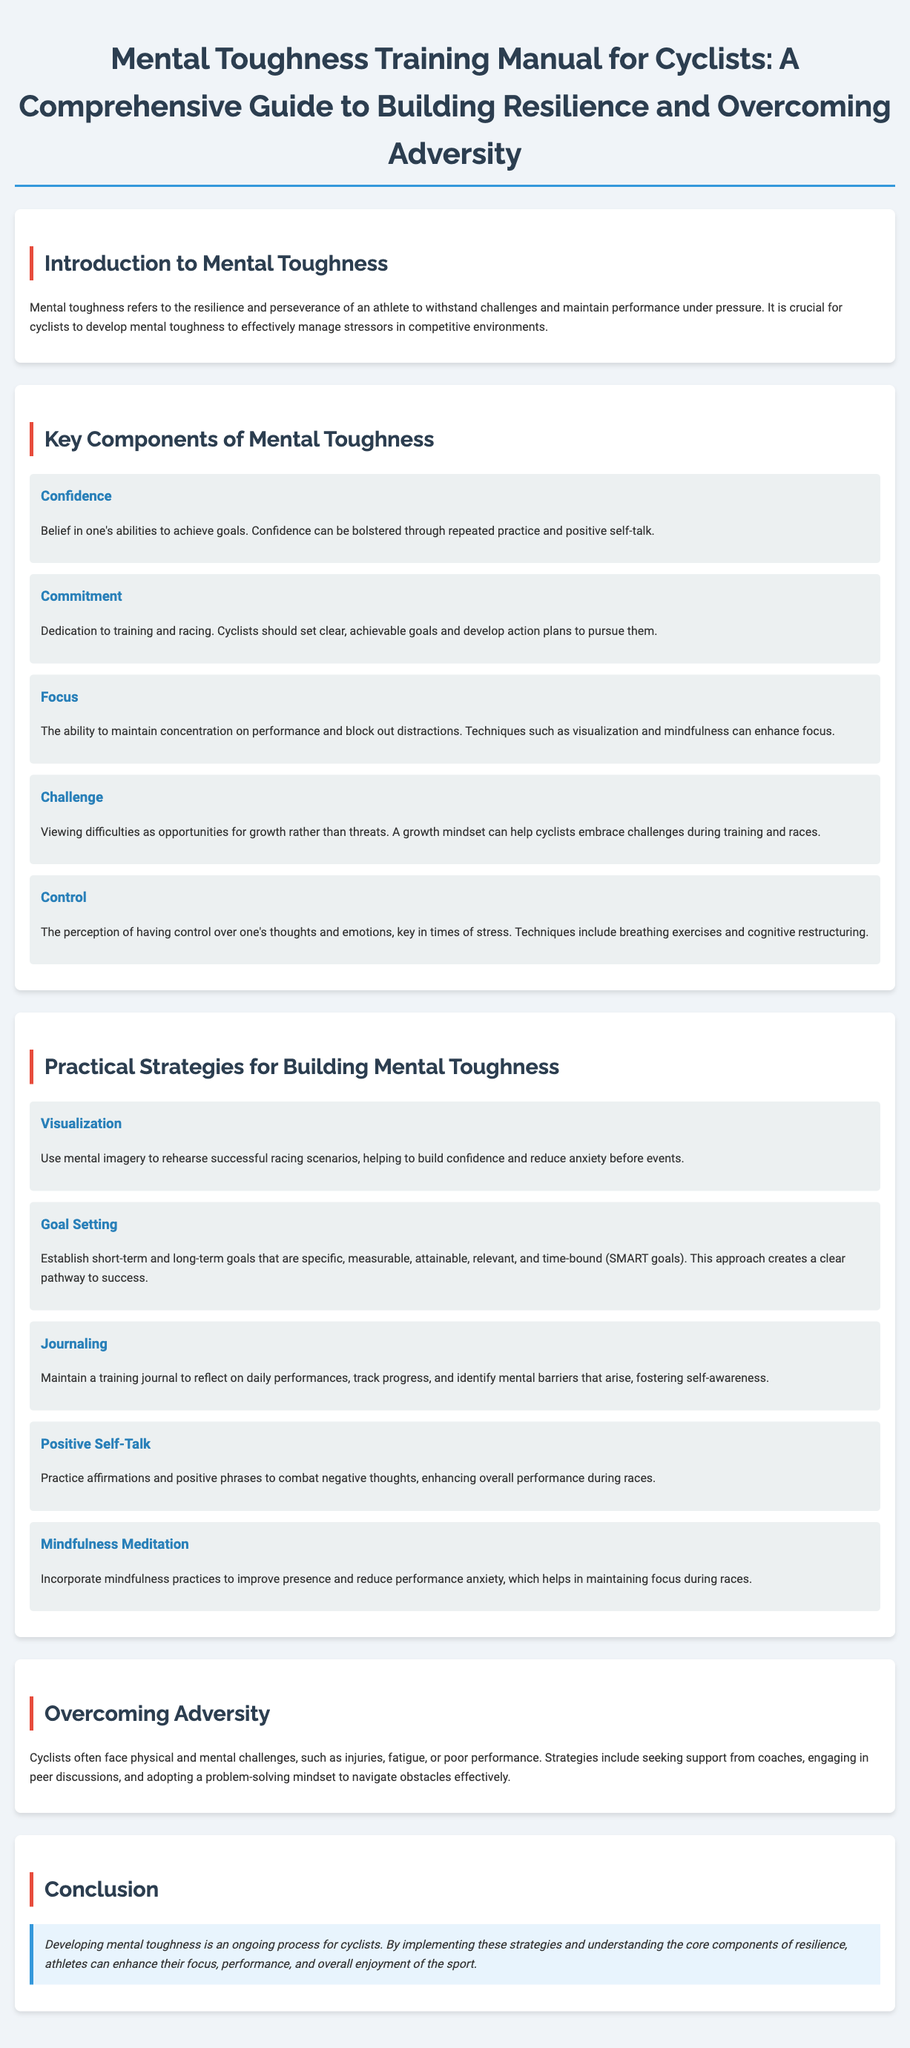what is the primary focus of mental toughness? The primary focus of mental toughness is the resilience and perseverance of an athlete to withstand challenges and maintain performance under pressure.
Answer: resilience and perseverance name one key component of mental toughness. Key components are specifically listed in the document; one of them is confidence.
Answer: confidence what does the acronym SMART in goal setting stand for? The acronym SMART refers to specific, measurable, attainable, relevant, and time-bound goals.
Answer: specific, measurable, attainable, relevant, time-bound which practice helps in reducing performance anxiety? The document mentions mindfulness meditation as a practice that helps in reducing performance anxiety.
Answer: mindfulness meditation what strategy involves maintaining a training journal? The strategy that involves maintaining a training journal is called journaling.
Answer: journaling how should cyclists view difficulties according to the manual? Cyclists should view difficulties as opportunities for growth rather than threats.
Answer: opportunities for growth what is a practical strategy for building mental toughness? The document lists several strategies; one example is visualization.
Answer: visualization what mindset should cyclists adopt to navigate obstacles effectively? Cyclists should adopt a problem-solving mindset to navigate obstacles effectively.
Answer: problem-solving mindset how can positive self-talk enhance performance? Positive self-talk helps combat negative thoughts, which enhances overall performance during races.
Answer: combat negative thoughts 